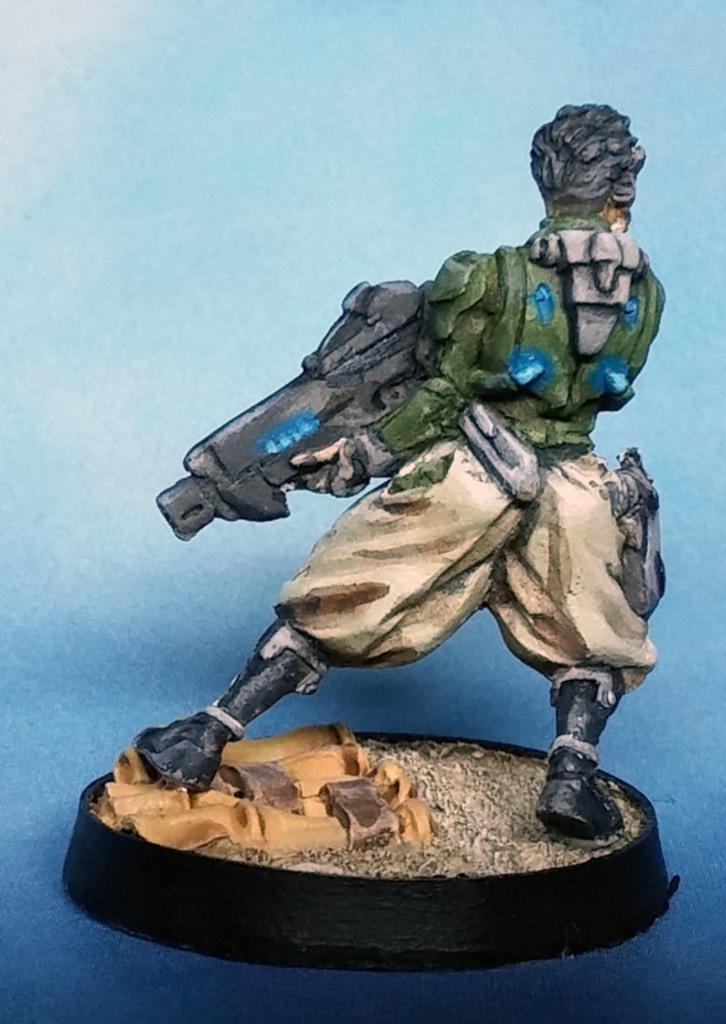What is the main subject of the image? There is a small statue in the image. What type of artwork is the image? The image appears to be a painting. What channel is the statue tuned to in the image? The image does not depict a television or any channel; it is a painting of a small statue. What type of bottle is placed next to the statue in the image? There is no bottle present in the image; it is a painting of a small statue. 